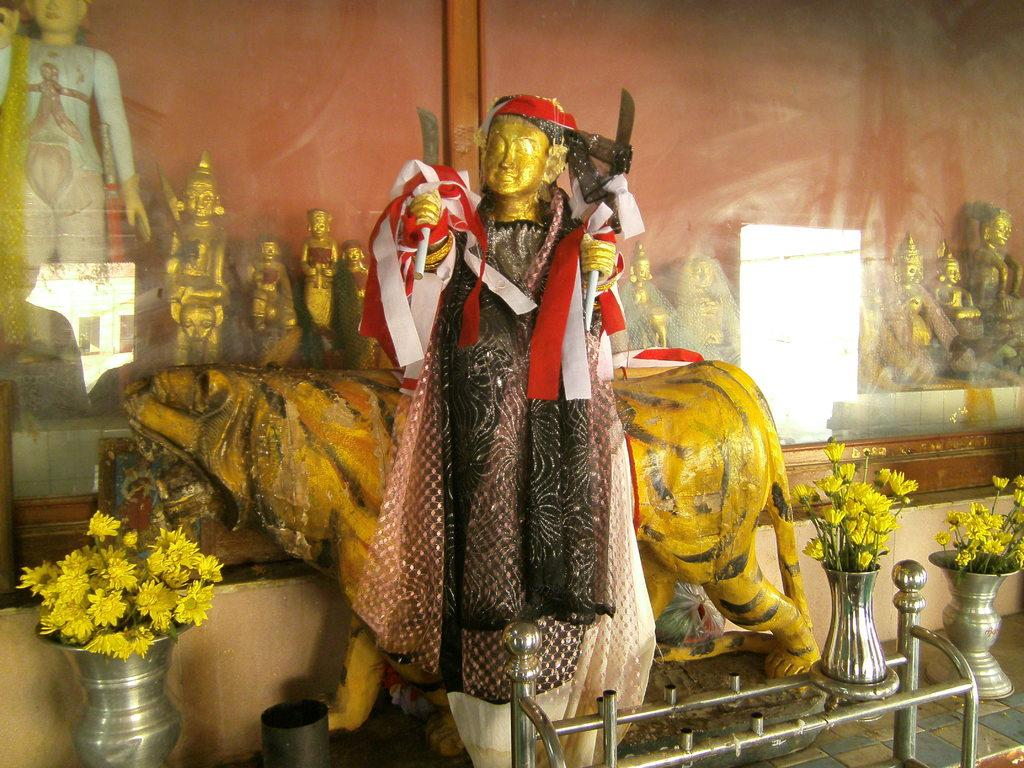What is the main subject in the image? There is a statue in the image. What other objects can be seen in the image? There are flower vases and metal rods in the image. Are there any religious or cultural elements in the image? Yes, there are idols in the image. How many tickets are visible in the image? There are no tickets present in the image. Are there any horses in the image? There are no horses present in the image. 